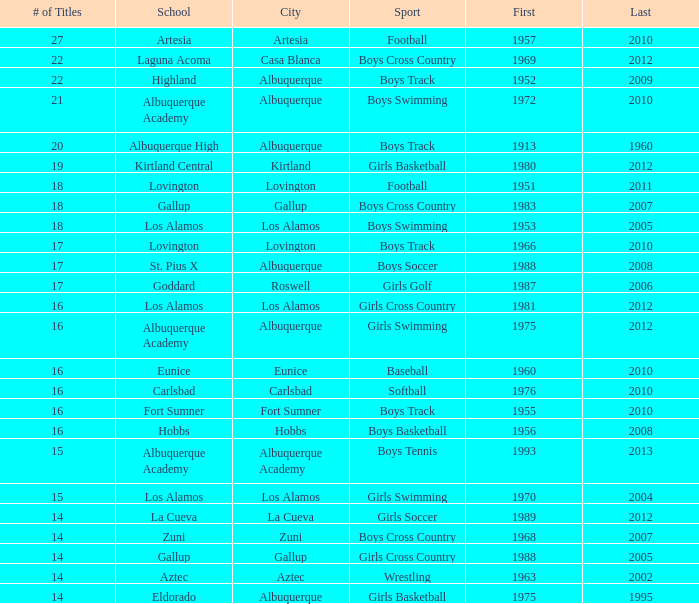Which city has the educational institution with fewer than 17 championships in boys' basketball, and the most recent title occurring post-2005? Hobbs. 